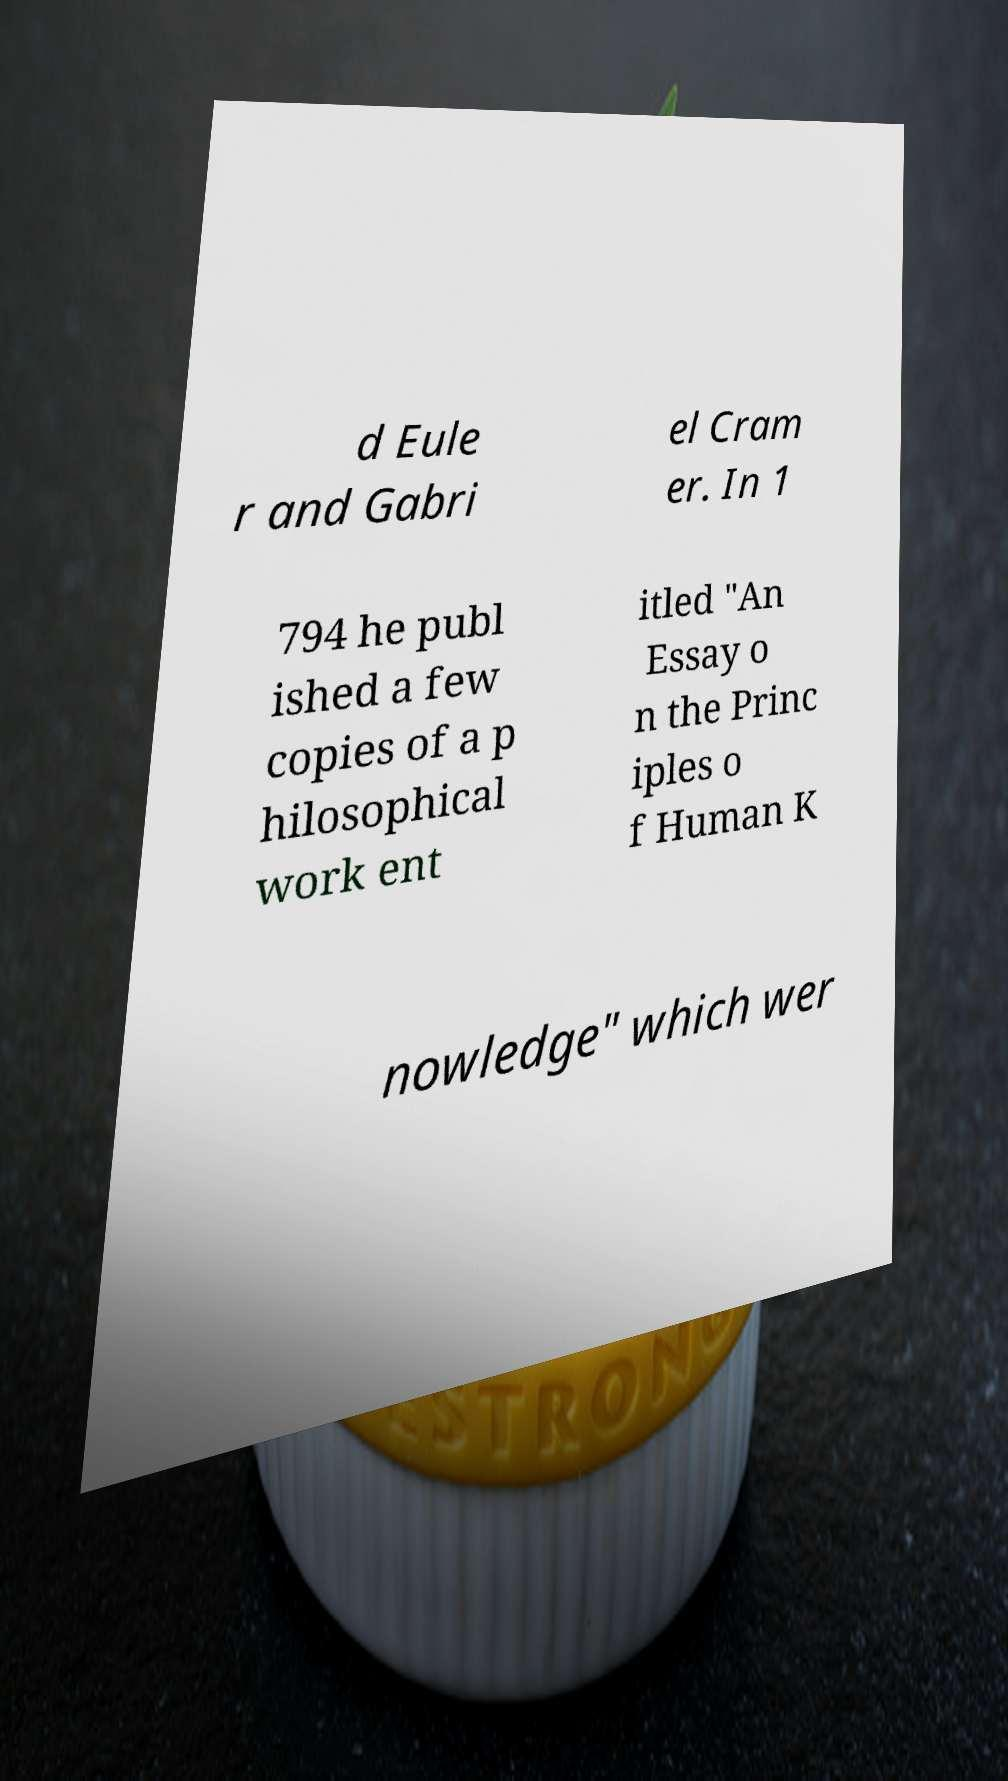Please read and relay the text visible in this image. What does it say? d Eule r and Gabri el Cram er. In 1 794 he publ ished a few copies of a p hilosophical work ent itled "An Essay o n the Princ iples o f Human K nowledge" which wer 